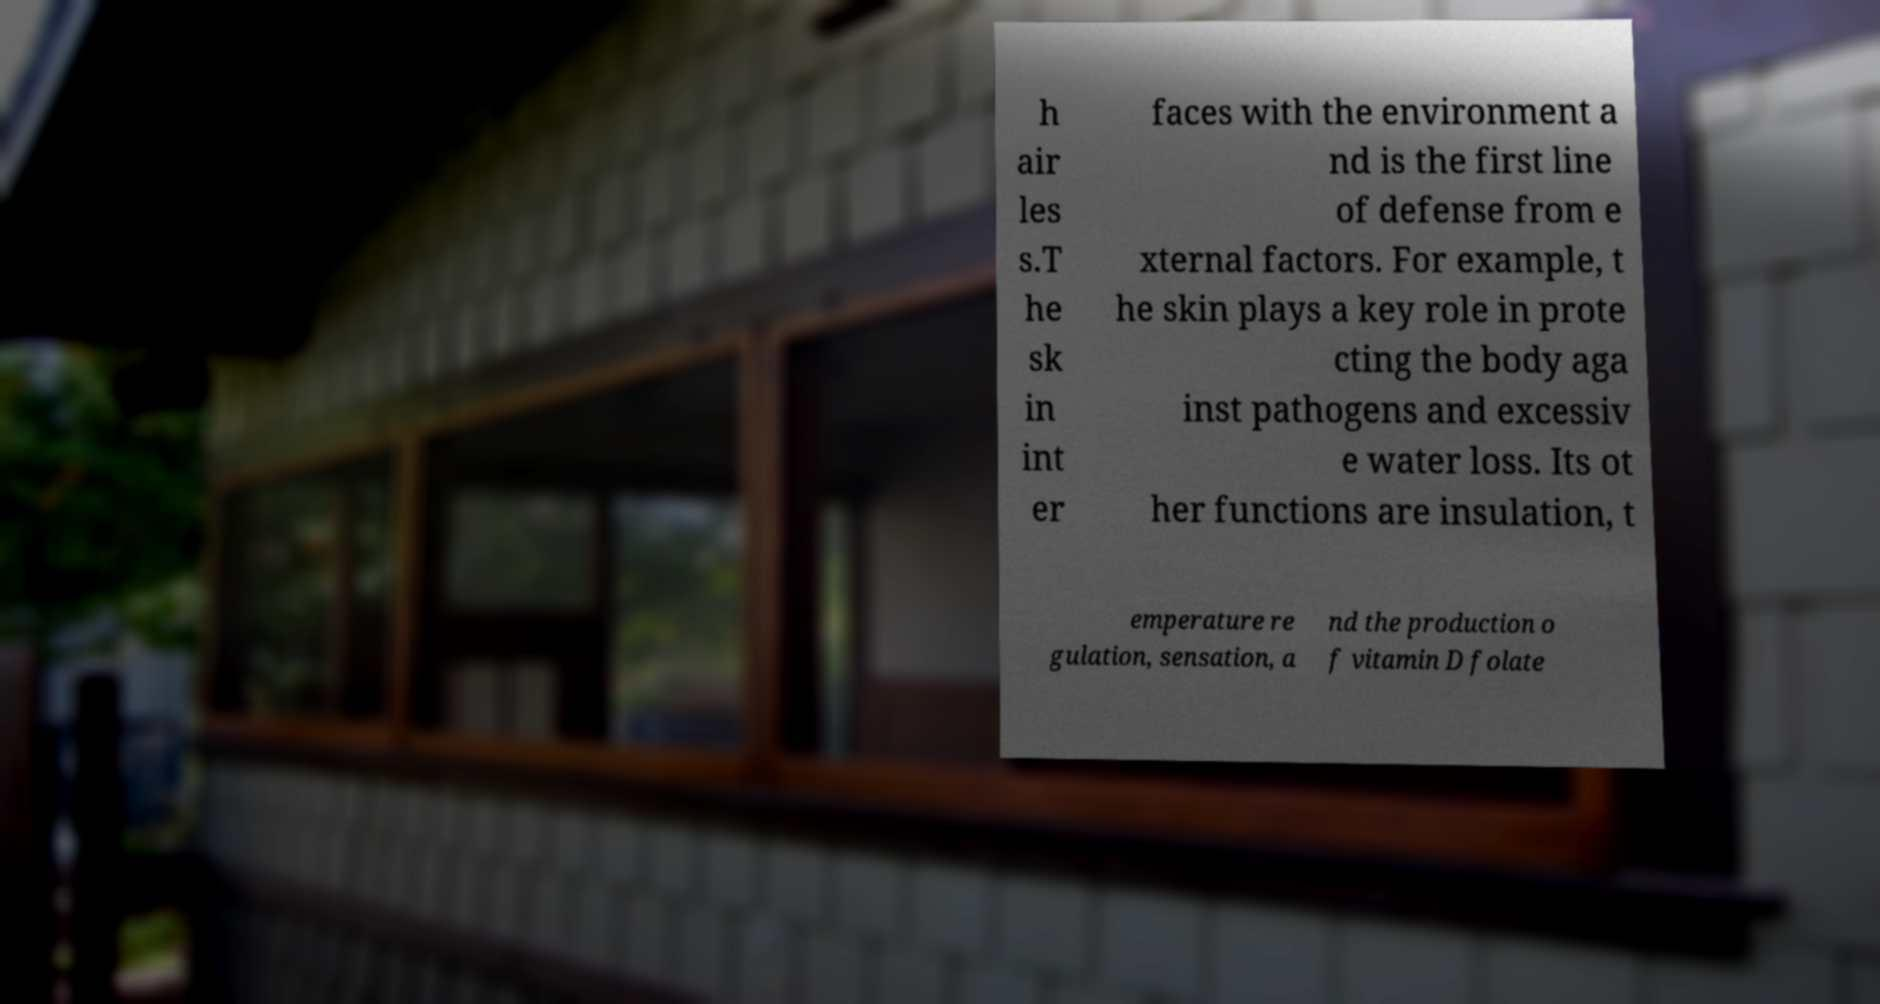Could you assist in decoding the text presented in this image and type it out clearly? h air les s.T he sk in int er faces with the environment a nd is the first line of defense from e xternal factors. For example, t he skin plays a key role in prote cting the body aga inst pathogens and excessiv e water loss. Its ot her functions are insulation, t emperature re gulation, sensation, a nd the production o f vitamin D folate 